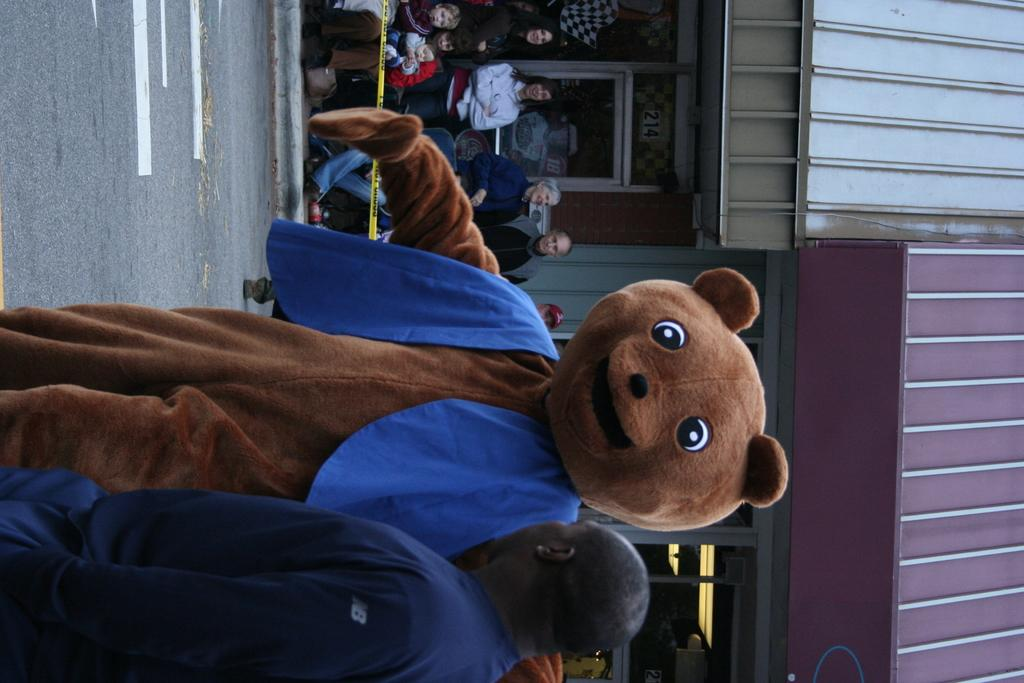What is the main subject of the image? There is a person in the image. What is unique about the person's appearance? The person is wearing a costume that resembles a teddy bear. Can you describe the surroundings of the person? There are other people visible in the background of the image, and there are two buildings in the background as well. What type of tail can be seen on the person in the image? There is no tail visible on the person in the image, as they are wearing a teddy bear costume. Can you tell me how many fans are present in the image? There is no fan visible in the image. 